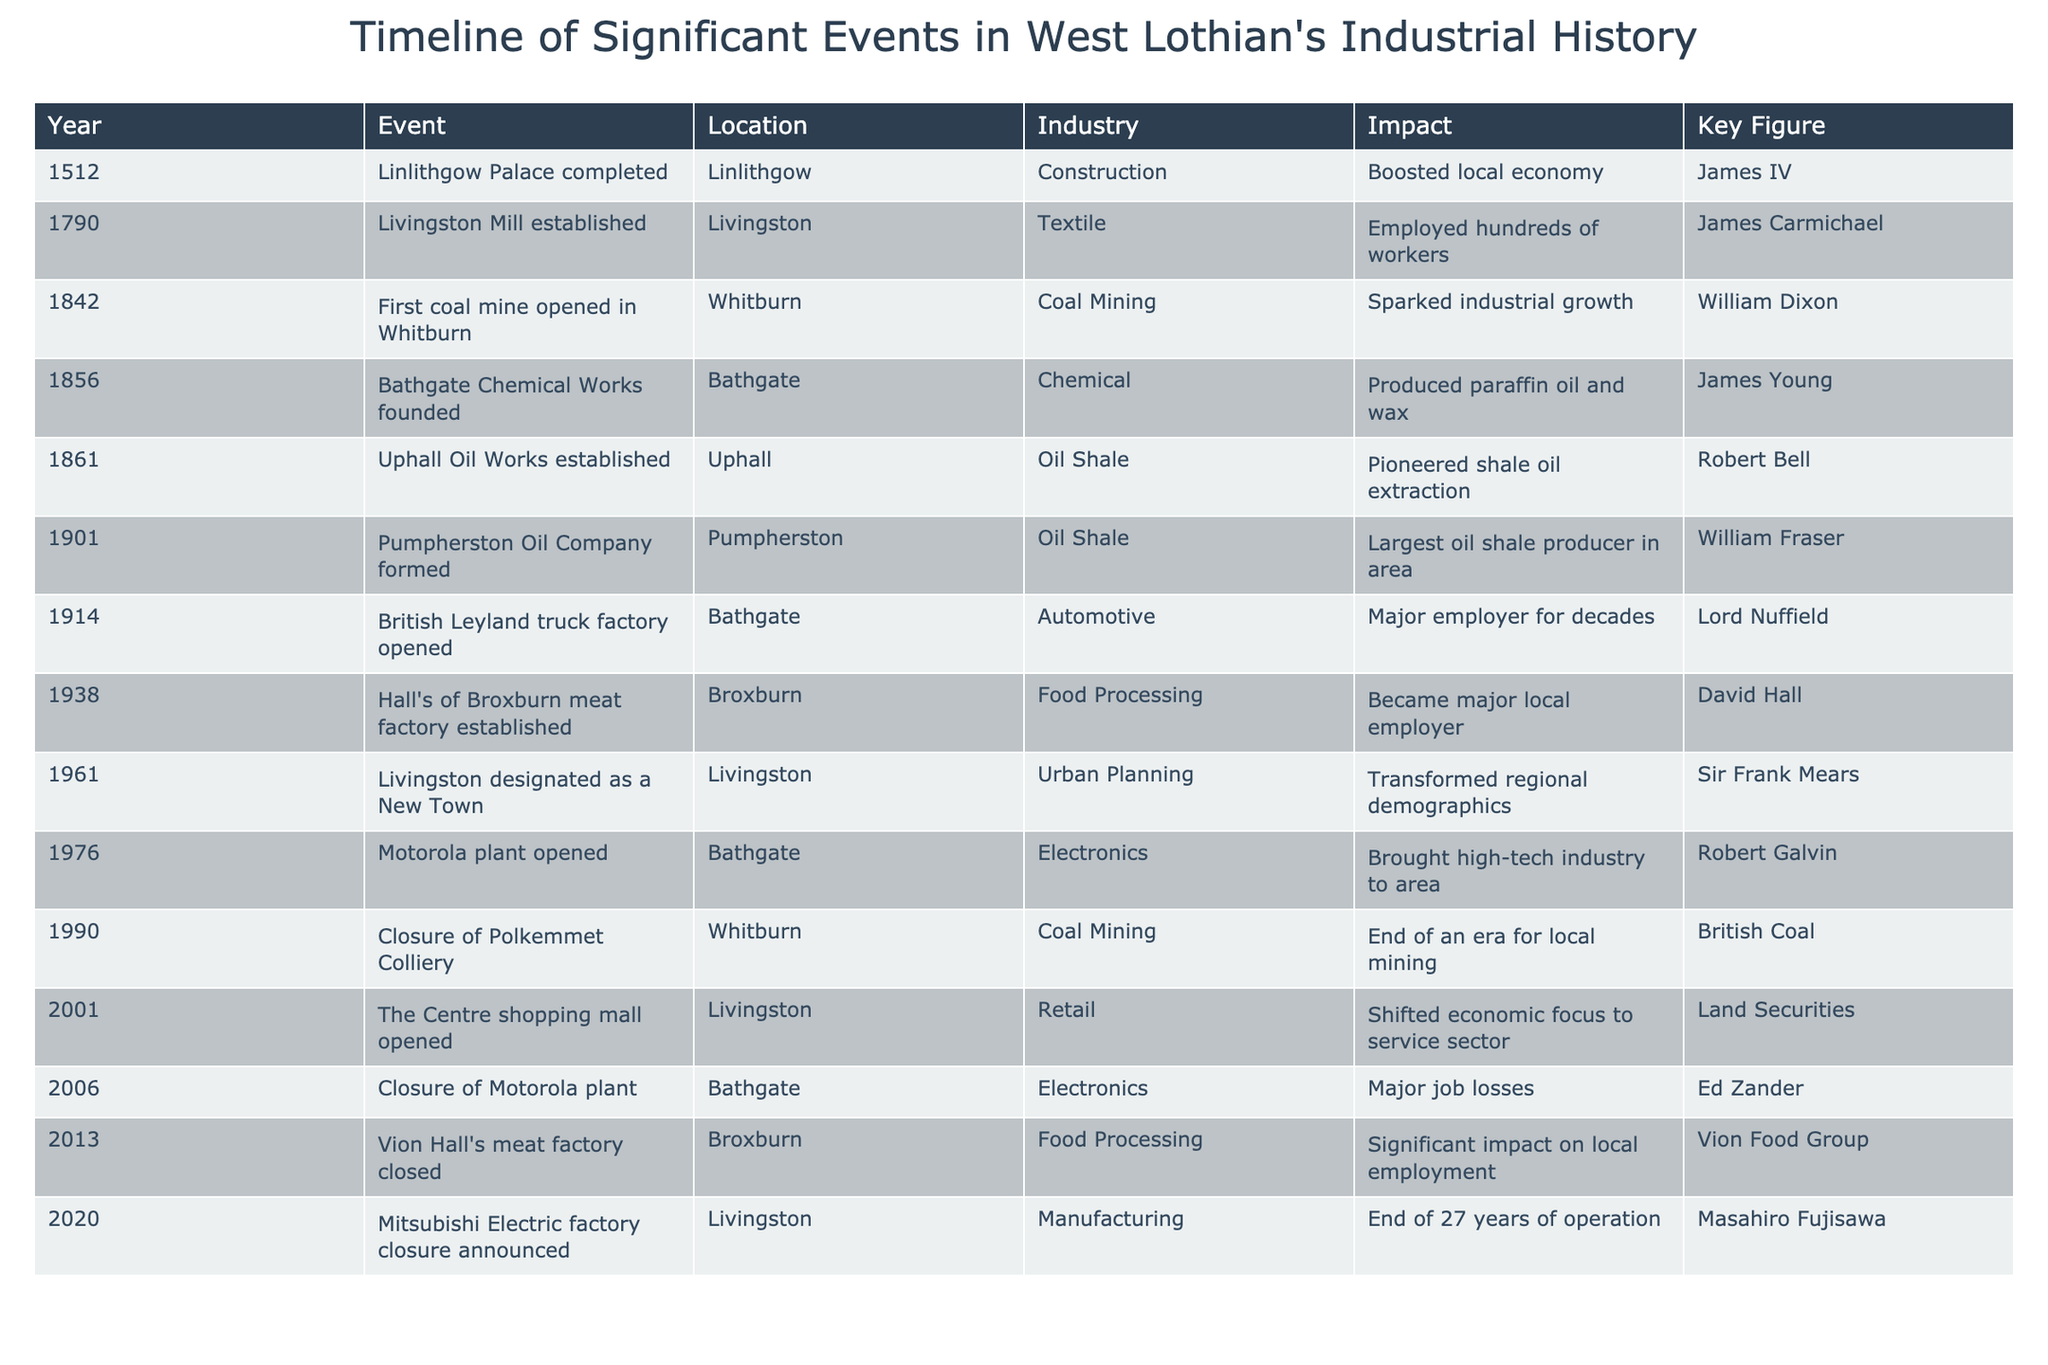What was the first significant event in West Lothian's industrial history? The first event listed in the table is the completion of Linlithgow Palace in 1512, which is noted as a significant construction achievement.
Answer: Linlithgow Palace completed in 1512 Which location had the largest oil shale production facility in the area? According to the table, the Pumpherston Oil Company, formed in 1901, is identified as the largest oil shale producer in the area, which is located in Pumpherston.
Answer: Pumpherston What year did the first coal mine open in West Lothian? Looking at the table, the first coal mine opened in Whitburn in the year 1842.
Answer: 1842 Was Livingston designated as a New Town before or after the closure of Polkemmet Colliery? The table indicates Livingston was designated as a New Town in 1961, while the Polkemmet Colliery closure happened in 1990. Since 1961 comes before 1990, the designation occurred first.
Answer: Before How many years were there between the establishment of the Bathgate Chemical Works and the closure of the Vion Hall's meat factory? Bathgate Chemical Works was founded in 1856 and the Vion Hall's meat factory was closed in 2013; the difference is 2013 - 1856 = 157 years.
Answer: 157 years Did the closure of the Motorola plant in Bathgate occur before or after the establishment of the meat factory in Broxburn? The table shows that the meat factory in Broxburn was established in 1938 and the Motorola plant closed in 2006, indicating that the plant closure occurred much later than the factory establishment.
Answer: After Which industry had the most events listed in the table? By analyzing the table, it appears that the Oil Shale industry has three significant events: the establishment of Uphall Oil Works, the formation of the Pumpherston Oil Company, and the Motorola plant's closure.
Answer: Oil Shale List the key figures associated with the opening of the British Leyland truck factory and the Motorola plant in Bathgate. The table states that Lord Nuffield is the key figure for the opening of the British Leyland truck factory in 1914, and Robert Galvin is associated with the opening of the Motorola plant in 1976.
Answer: Lord Nuffield and Robert Galvin How many industries experienced a significant closure between 1990 and 2020? The table indicates two significant closures in that period: Polkemmet Colliery in 1990 and Mitsubishi Electric factory closure announced in 2020, suggesting there were no other closures listed.
Answer: 2 What event had a significant impact on local employment in Broxburn? The establishment of Hall's of Broxburn meat factory in 1938 is noted to have become a major local employer, indicating its significance to local employment.
Answer: Hall's of Broxburn meat factory established in 1938 